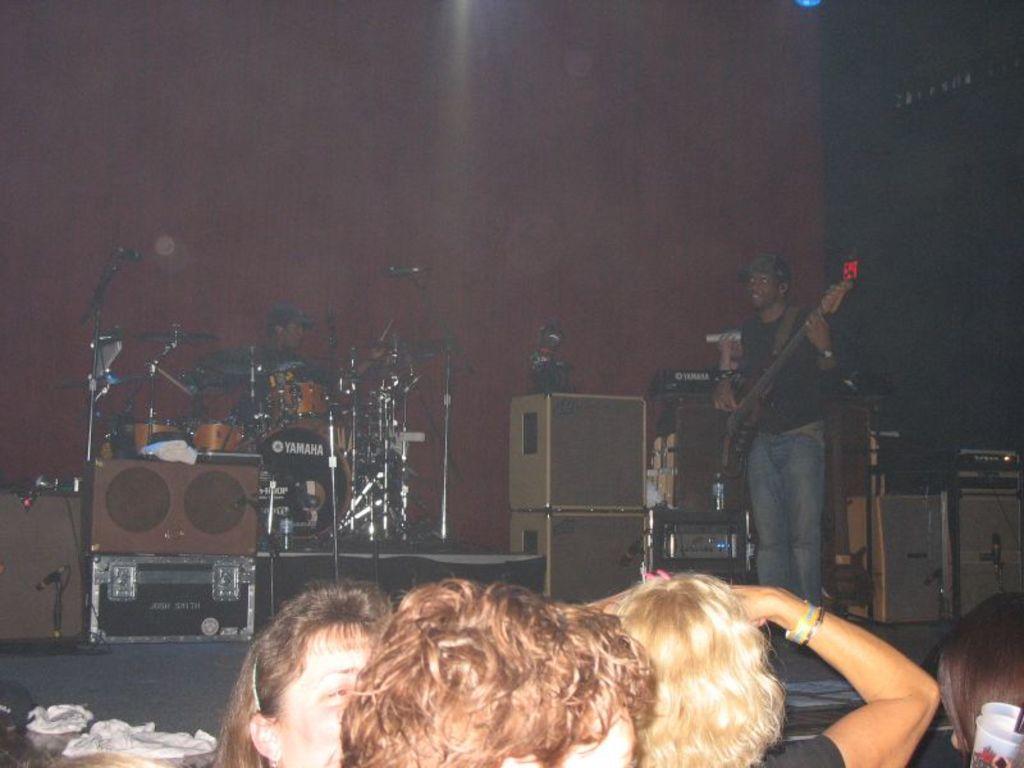In one or two sentences, can you explain what this image depicts? In this image in front there are people. In front of them there are people playing musical instruments on the stage. In the background of the image there is a wall. 